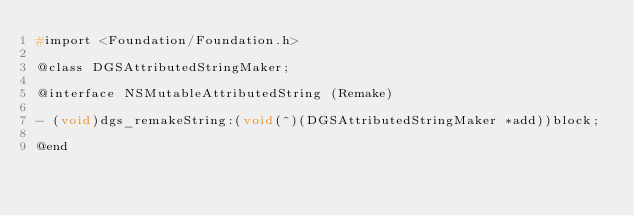Convert code to text. <code><loc_0><loc_0><loc_500><loc_500><_C_>#import <Foundation/Foundation.h>

@class DGSAttributedStringMaker;

@interface NSMutableAttributedString (Remake)

- (void)dgs_remakeString:(void(^)(DGSAttributedStringMaker *add))block;

@end
</code> 